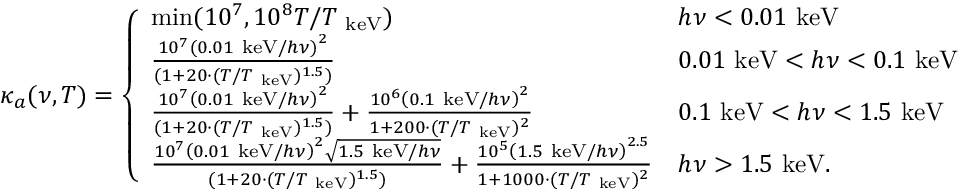<formula> <loc_0><loc_0><loc_500><loc_500>\kappa _ { a } ( \nu , T ) = \left \{ \begin{array} { l l } { \min ( 1 0 ^ { 7 } , 1 0 ^ { 8 } T / T _ { k e V } ) } & { h \nu < 0 . 0 1 k e V } \\ { \frac { 1 0 ^ { 7 } \left ( 0 . 0 1 k e V / h \nu \right ) ^ { 2 } } { ( 1 + 2 0 \cdot ( T / T _ { k e V } ) ^ { 1 . 5 } ) } } & { 0 . 0 1 k e V < h \nu < 0 . 1 k e V } \\ { \frac { 1 0 ^ { 7 } \left ( 0 . 0 1 k e V / h \nu \right ) ^ { 2 } } { ( 1 + 2 0 \cdot ( T / T _ { k e V } ) ^ { 1 . 5 } ) } + \frac { 1 0 ^ { 6 } \left ( 0 . 1 k e V / h \nu \right ) ^ { 2 } } { 1 + 2 0 0 \cdot ( T / T _ { k e V } ) ^ { 2 } } } & { 0 . 1 k e V < h \nu < 1 . 5 k e V } \\ { \frac { 1 0 ^ { 7 } \left ( 0 . 0 1 k e V / h \nu \right ) ^ { 2 } \sqrt { 1 . 5 k e V / h \nu } } { ( 1 + 2 0 \cdot ( T / T _ { k e V } ) ^ { 1 . 5 } ) } + \frac { 1 0 ^ { 5 } \left ( 1 . 5 k e V / h \nu \right ) ^ { 2 . 5 } } { 1 + 1 0 0 0 \cdot ( T / T _ { k e V } ) ^ { 2 } } } & { h \nu > 1 . 5 k e V . } \end{array}</formula> 